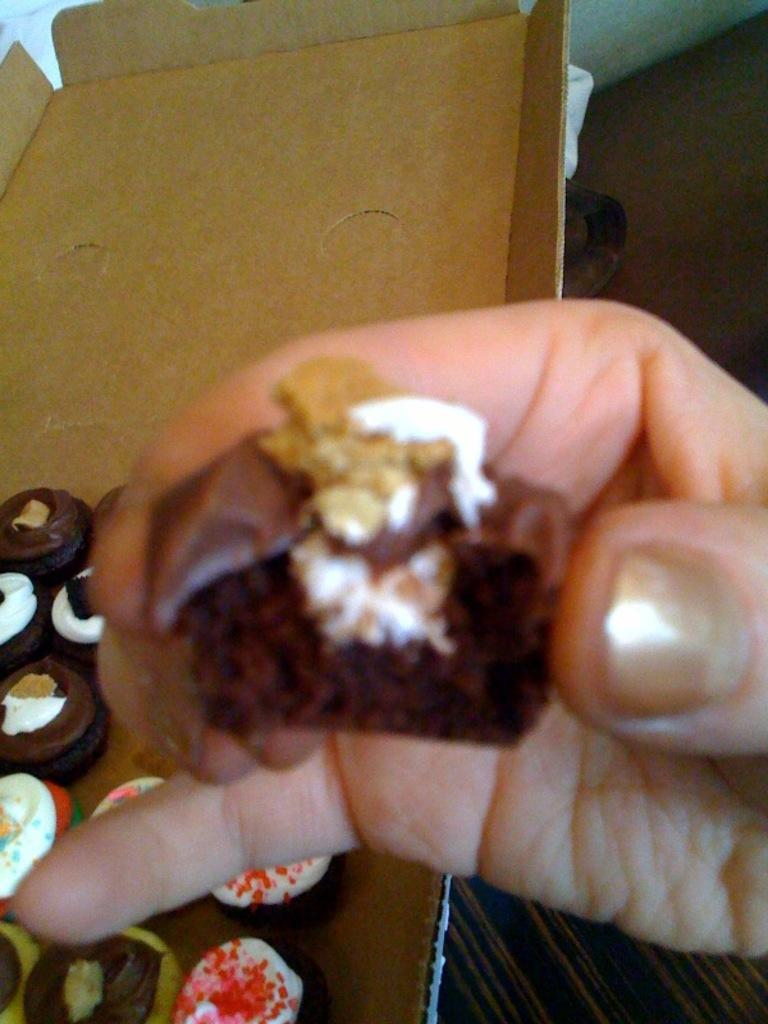What is the human hand holding in the image? A human hand is holding a food item in the image. What type of food item is being held by the hand? The food item is not specified, but it is being held by a human hand. What other food items can be seen in the image? There are cakes in the image. What other object is present in the image besides the food items? There is a box in the image. What month is it in the image? The month is not mentioned or depicted in the image. How many dolls are present in the image? There are no dolls present in the image. 